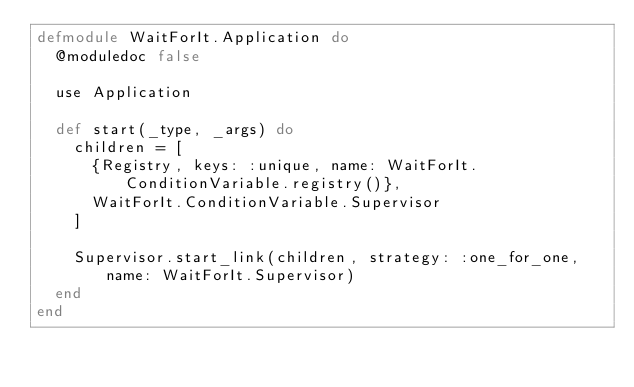<code> <loc_0><loc_0><loc_500><loc_500><_Elixir_>defmodule WaitForIt.Application do
  @moduledoc false

  use Application

  def start(_type, _args) do
    children = [
      {Registry, keys: :unique, name: WaitForIt.ConditionVariable.registry()},
      WaitForIt.ConditionVariable.Supervisor
    ]

    Supervisor.start_link(children, strategy: :one_for_one, name: WaitForIt.Supervisor)
  end
end
</code> 